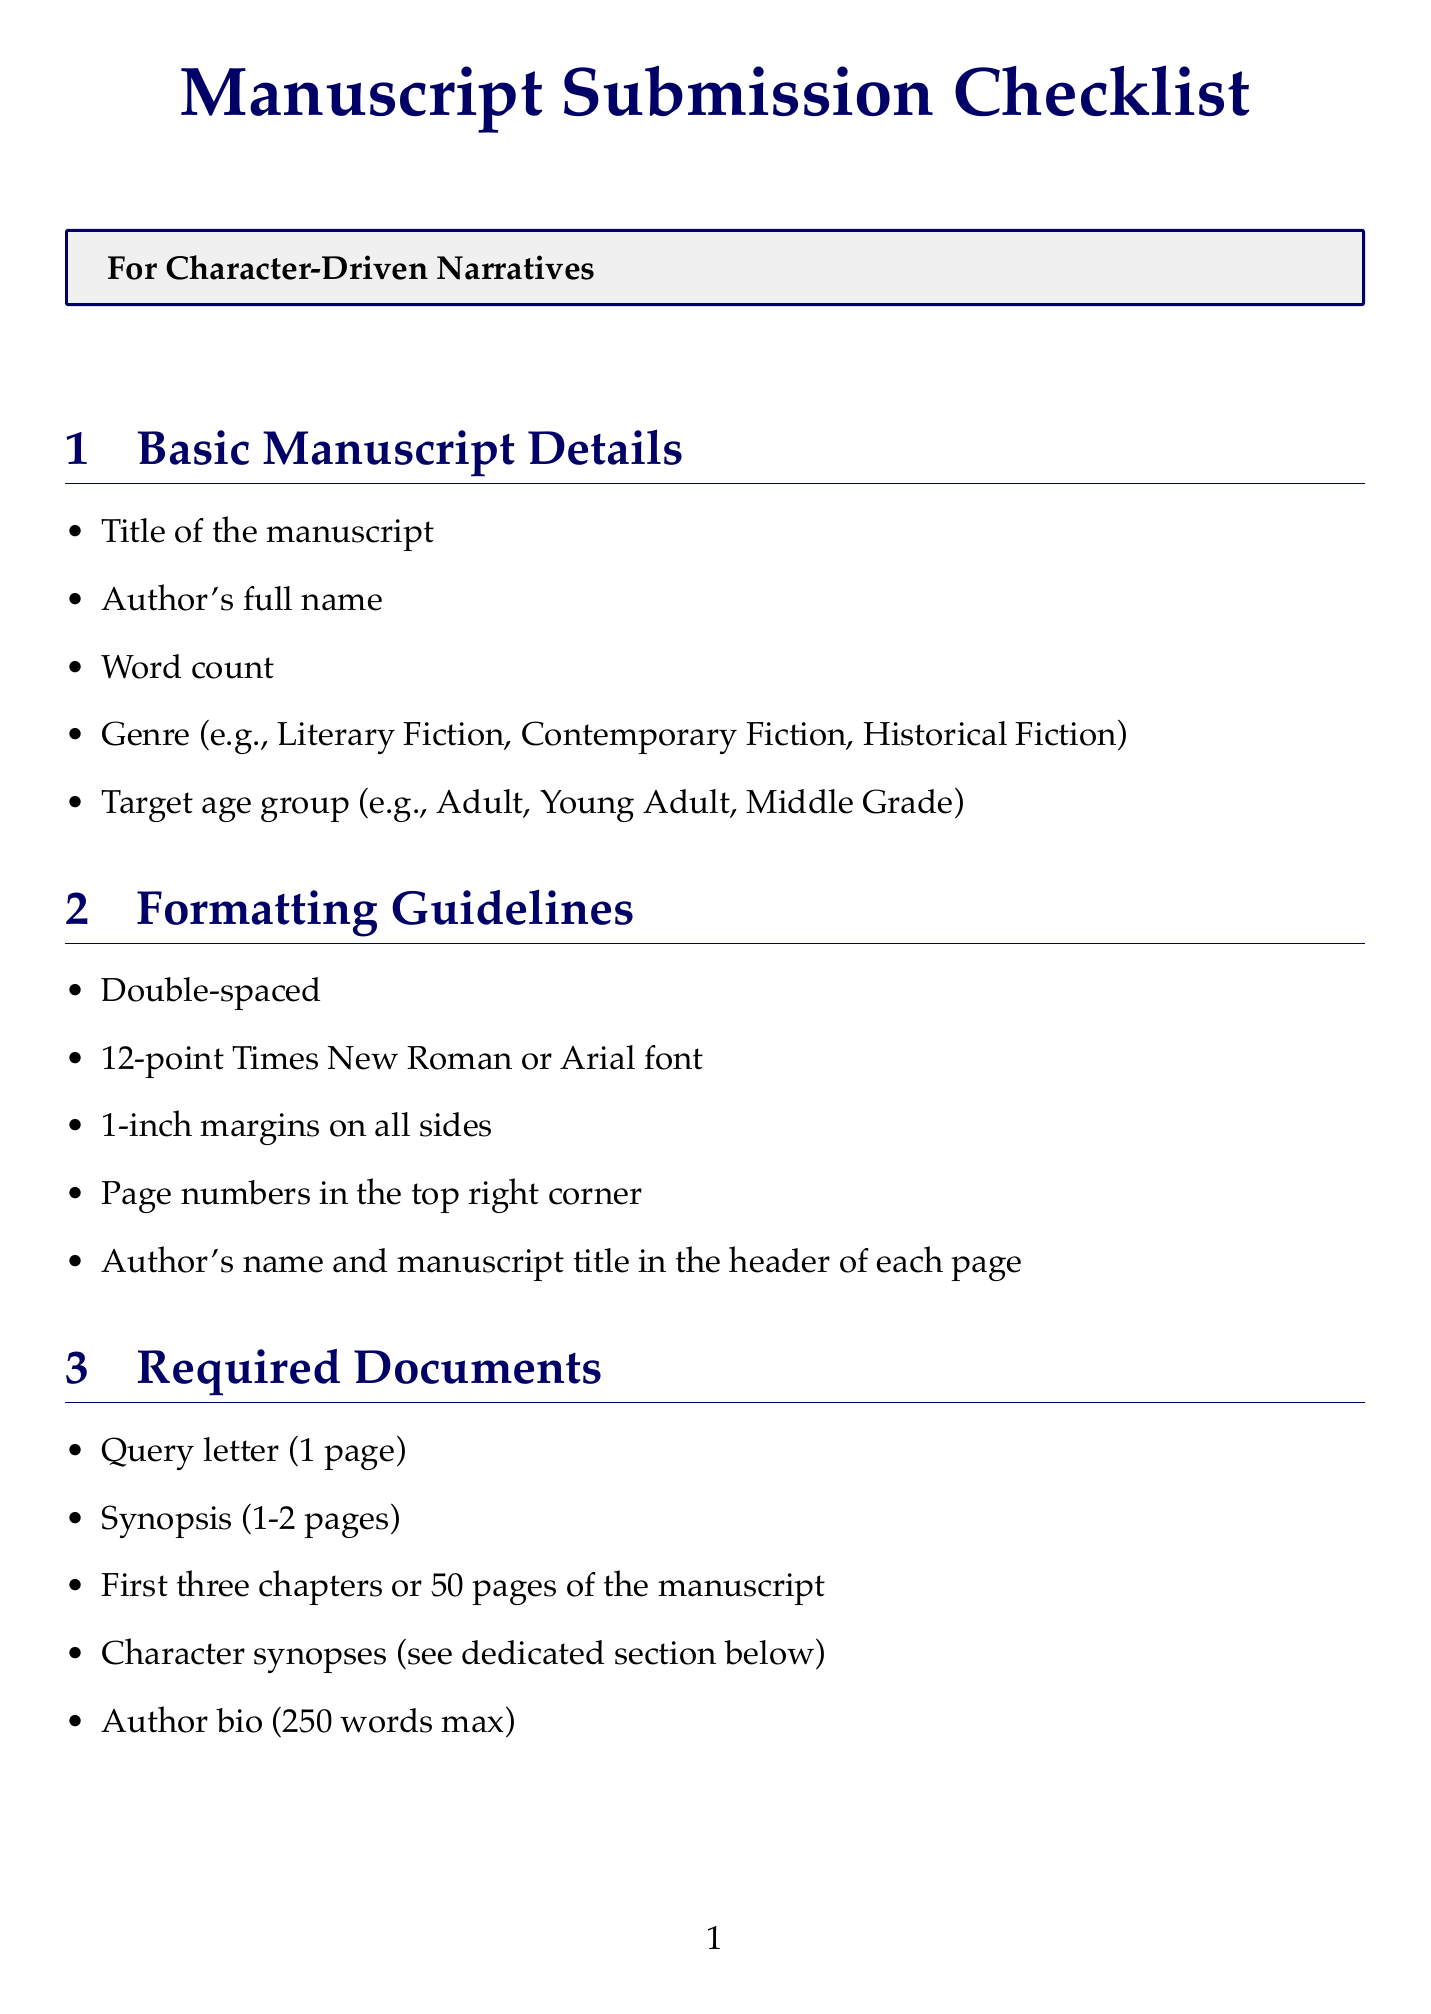What is the maximum word count for the character synopses? The document states that each character synopsis should be a brief synopsis of 250 words max per character.
Answer: 250 words What items are required for the manuscript submission? The required documents section lists specific items needed for submission, including a query letter and author bio.
Answer: Query letter, synopsis, first three chapters or 50 pages, character synopses, author bio How many bullets are under the "Narrative Focus" section? The narrative focus section contains five items listed for ensuring character-driven storytelling.
Answer: 5 What font size should the manuscript be formatted in? The formatting guidelines specify a 12-point font size for the manuscript.
Answer: 12-point What is the target age group example mentioned in the document? The basic manuscript details section provides examples of target age groups.
Answer: Adult Are character relationships mentioned in the character authenticity checklist? The character authenticity checklist includes questions regarding the complexity and nuance of character relationships.
Answer: Yes Which section focuses specifically on character-driven narratives? The document includes a section specifically highlighting narrative focus in relation to characters.
Answer: Narrative Focus What is the submission email address provided? The submission guidelines section states the email address for submissions.
Answer: submissions@literaryagency.com How many comparable titles should be listed in the comparison section? The comparable titles section indicates how many titles should be listed for comparison.
Answer: 2-3 